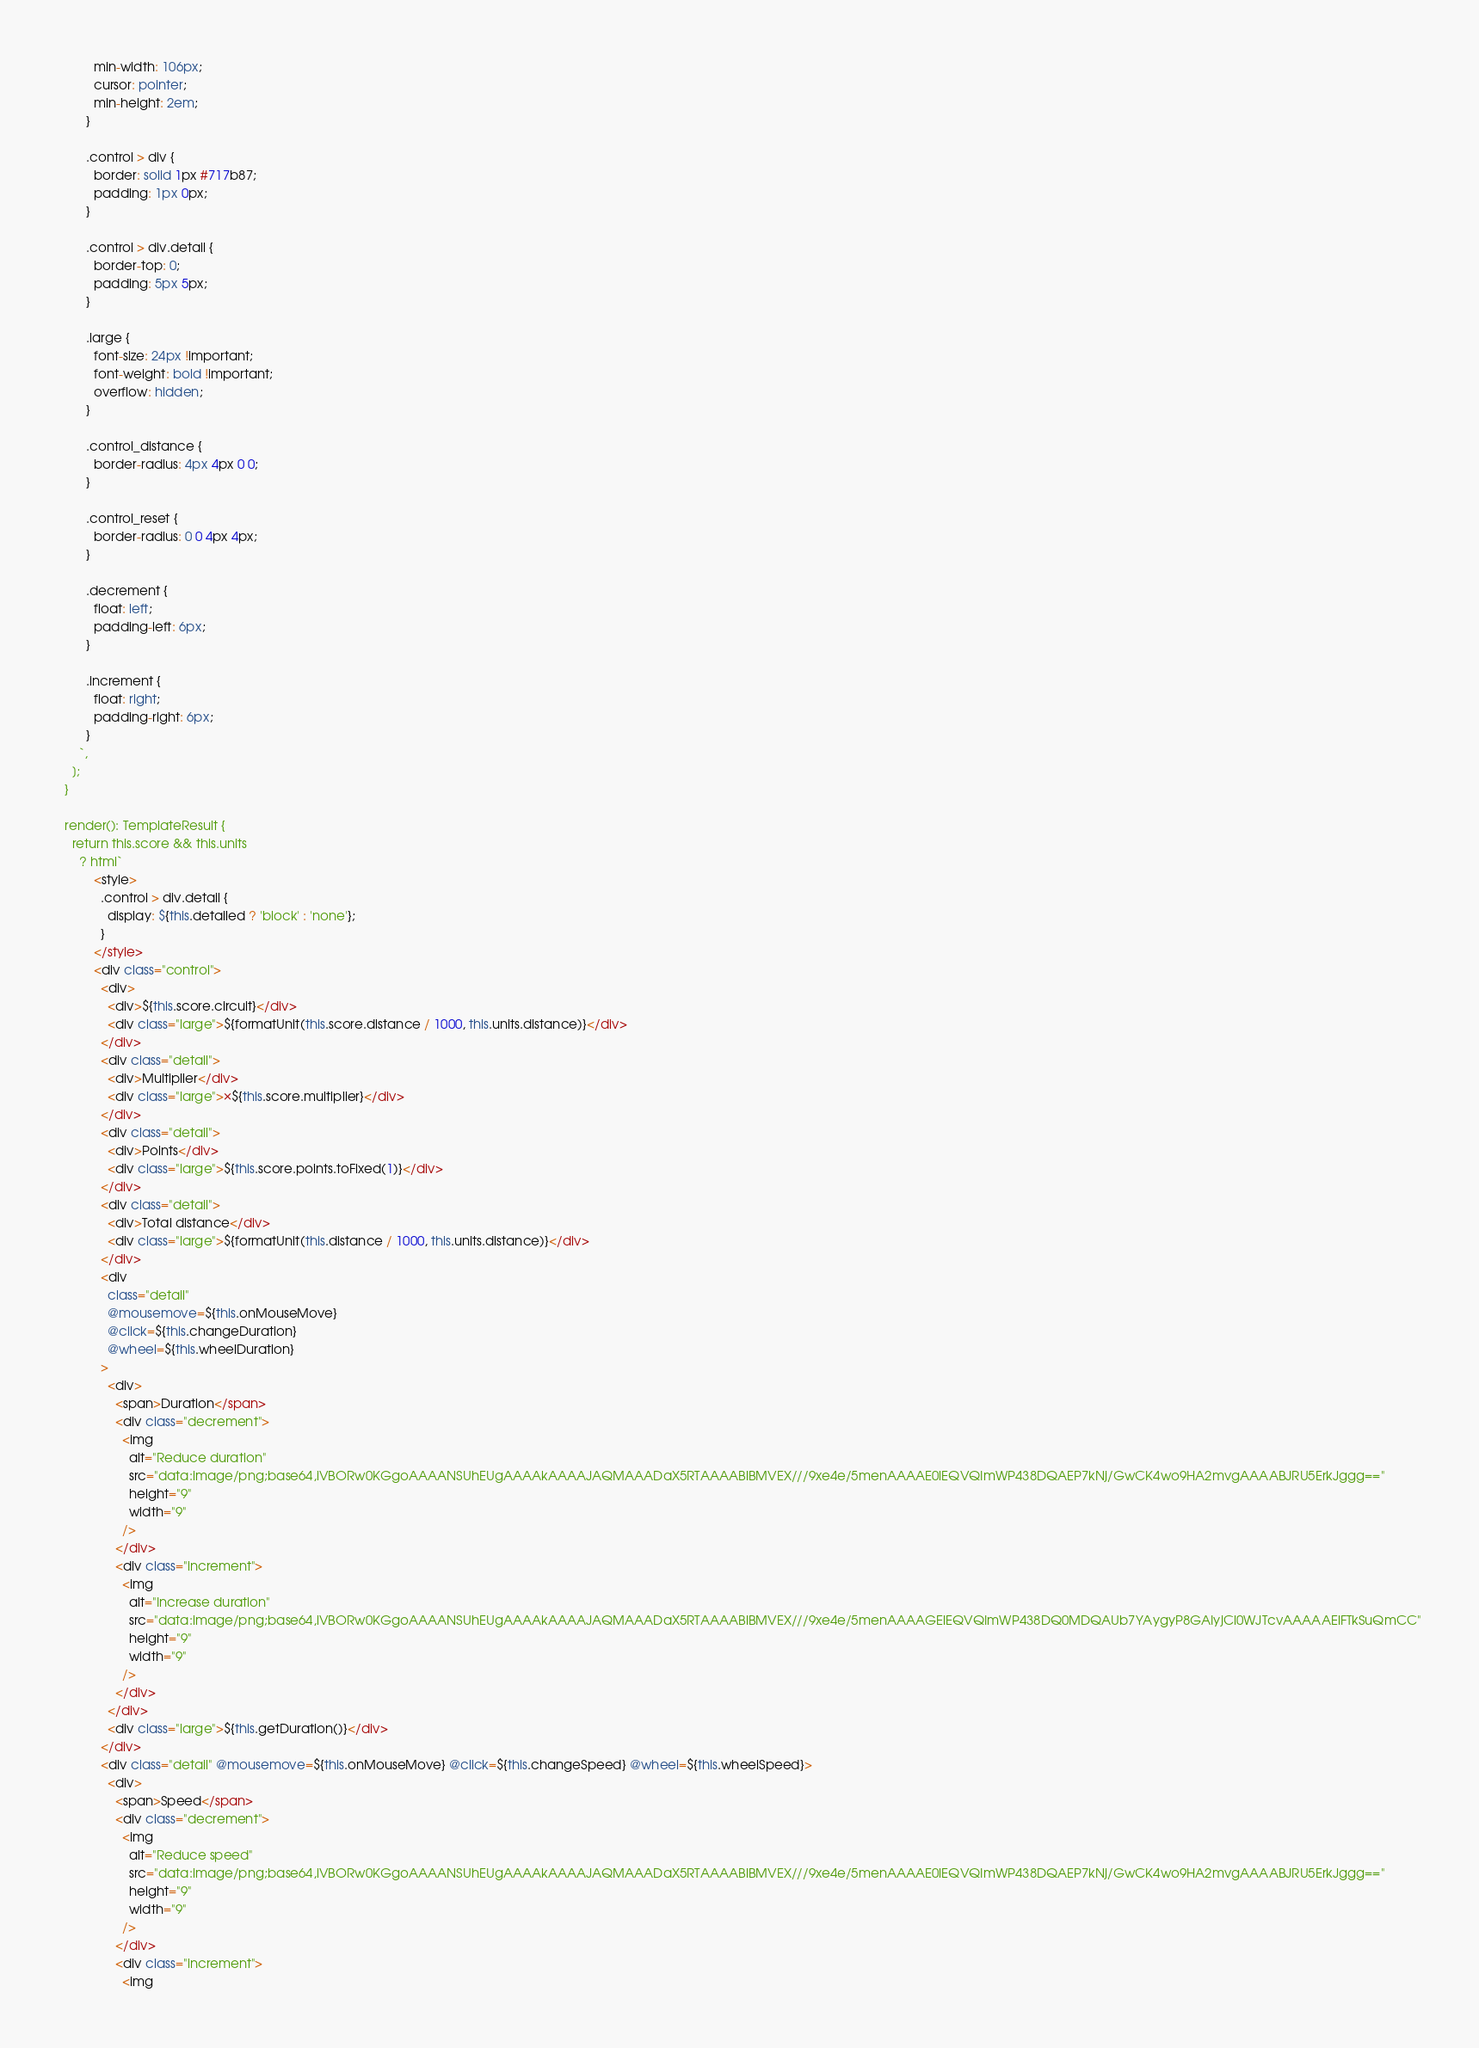Convert code to text. <code><loc_0><loc_0><loc_500><loc_500><_TypeScript_>          min-width: 106px;
          cursor: pointer;
          min-height: 2em;
        }

        .control > div {
          border: solid 1px #717b87;
          padding: 1px 0px;
        }

        .control > div.detail {
          border-top: 0;
          padding: 5px 5px;
        }

        .large {
          font-size: 24px !important;
          font-weight: bold !important;
          overflow: hidden;
        }

        .control_distance {
          border-radius: 4px 4px 0 0;
        }

        .control_reset {
          border-radius: 0 0 4px 4px;
        }

        .decrement {
          float: left;
          padding-left: 6px;
        }

        .increment {
          float: right;
          padding-right: 6px;
        }
      `,
    ];
  }

  render(): TemplateResult {
    return this.score && this.units
      ? html`
          <style>
            .control > div.detail {
              display: ${this.detailed ? 'block' : 'none'};
            }
          </style>
          <div class="control">
            <div>
              <div>${this.score.circuit}</div>
              <div class="large">${formatUnit(this.score.distance / 1000, this.units.distance)}</div>
            </div>
            <div class="detail">
              <div>Multiplier</div>
              <div class="large">×${this.score.multiplier}</div>
            </div>
            <div class="detail">
              <div>Points</div>
              <div class="large">${this.score.points.toFixed(1)}</div>
            </div>
            <div class="detail">
              <div>Total distance</div>
              <div class="large">${formatUnit(this.distance / 1000, this.units.distance)}</div>
            </div>
            <div
              class="detail"
              @mousemove=${this.onMouseMove}
              @click=${this.changeDuration}
              @wheel=${this.wheelDuration}
            >
              <div>
                <span>Duration</span>
                <div class="decrement">
                  <img
                    alt="Reduce duration"
                    src="data:image/png;base64,iVBORw0KGgoAAAANSUhEUgAAAAkAAAAJAQMAAADaX5RTAAAABlBMVEX///9xe4e/5menAAAAE0lEQVQImWP438DQAEP7kNj/GwCK4wo9HA2mvgAAAABJRU5ErkJggg=="
                    height="9"
                    width="9"
                  />
                </div>
                <div class="increment">
                  <img
                    alt="Increase duration"
                    src="data:image/png;base64,iVBORw0KGgoAAAANSUhEUgAAAAkAAAAJAQMAAADaX5RTAAAABlBMVEX///9xe4e/5menAAAAGElEQVQImWP438DQ0MDQAUb7YAygyP8GAIyjCl0WJTcvAAAAAElFTkSuQmCC"
                    height="9"
                    width="9"
                  />
                </div>
              </div>
              <div class="large">${this.getDuration()}</div>
            </div>
            <div class="detail" @mousemove=${this.onMouseMove} @click=${this.changeSpeed} @wheel=${this.wheelSpeed}>
              <div>
                <span>Speed</span>
                <div class="decrement">
                  <img
                    alt="Reduce speed"
                    src="data:image/png;base64,iVBORw0KGgoAAAANSUhEUgAAAAkAAAAJAQMAAADaX5RTAAAABlBMVEX///9xe4e/5menAAAAE0lEQVQImWP438DQAEP7kNj/GwCK4wo9HA2mvgAAAABJRU5ErkJggg=="
                    height="9"
                    width="9"
                  />
                </div>
                <div class="increment">
                  <img</code> 